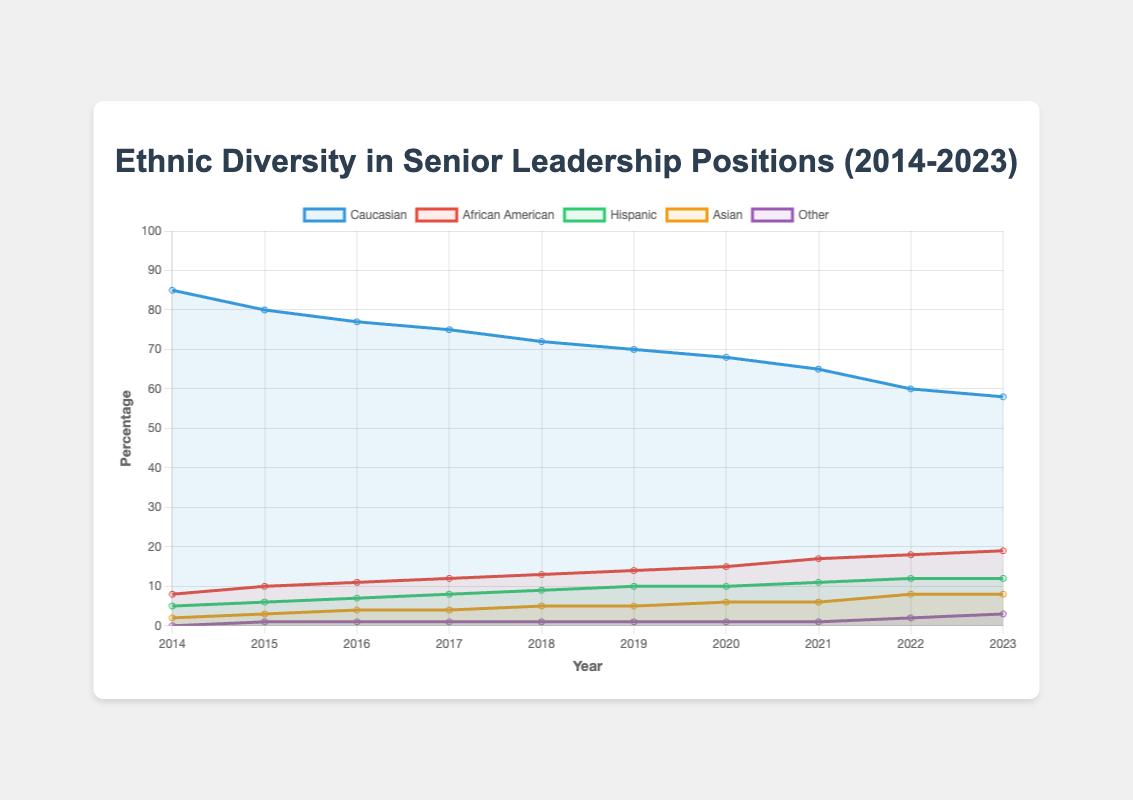What is the change in the percentage of Caucasian representation from 2014 to 2023? By looking at the start value for Caucasians in 2014 and subtracting the end value in 2023, we get 85 - 58 = 27.
Answer: 27 Which ethnic group shows the most significant increase in representation from 2014 to 2023? By comparing the difference in values from 2014 to 2023, African Americans increased from 8% to 19%, a net increase of 11%. This is more significant than other groups.
Answer: African American In 2018, did the representation of Hispanic individuals exceed 8%? By checking the value for Hispanic individuals in 2018, it is 9%, which exceeds 8%.
Answer: Yes What's the average percentage of Asian representation from 2014 to 2023? Adding up the Asian percentages from each year (2 + 3 + 4 + 4 + 5 + 5 + 6 + 6 + 8 + 8) gives 51. Dividing by the number of years, 51/10, we get 5.1.
Answer: 5.1 Compare the representation of "Other" in 2023 with 2014. The representation of "Other" in 2023 is 3%, while in 2014 it was 0%, indicating an increase by 3%.
Answer: Increased by 3% Which year saw the greatest drop in the percentage of Caucasian representation? Comparing the percentage decrease year by year, 2014 to 2015 shows the largest drop (85% to 80%), a difference of 5%.
Answer: 2015 Did the representation of African American individuals ever decrease over the years shown? By looking at the data for African Americans each year from 2014 to 2023, the percentage consistently increased, not decreased.
Answer: No How does the trend of Asian representation compare visually to that of Hispanic individuals from 2014 to 2023? The visual trend for Asians shows a steady increase similar to Hispanics, but starting lower and generally increasing at a slower rate until 2022 where Asians equal Hispanics at 8% and then both plateau in 2023.
Answer: Similar, with Asians starting lower What is the combined increase in the percentage of Hispanic and Asian representation from 2014 to 2023? Hispanic increased from 5% to 12% (an increase of 7%) and Asian from 2% to 8% (an increase of 6%), thus the combined increase is 7 + 6 = 13%.
Answer: 13% Which group had the least representation in 2023 and what was the percentage? By examining the 2023 data, the "Other" group had the least representation at 3%.
Answer: Other, 3% 